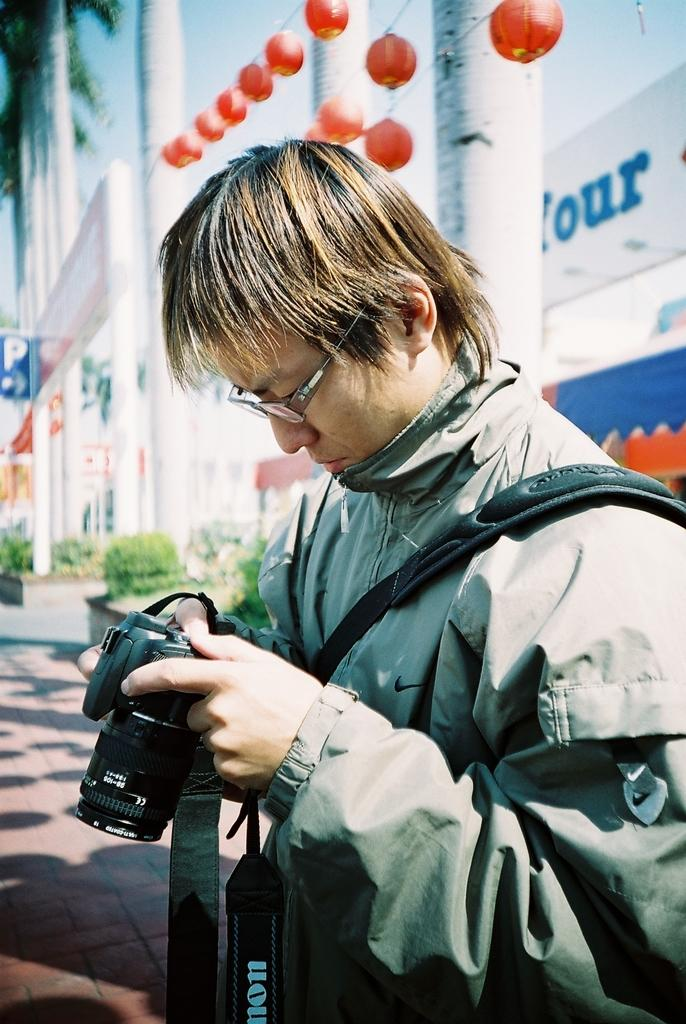What is the main structure in the image? There is a building in the image. Who is present in the image besides the building? There is a man in the image. What is the man holding in the image? The man is holding a camera. What type of jam is the man spreading on the bread in the image? There is no bread or jam present in the image; the man is holding a camera. 